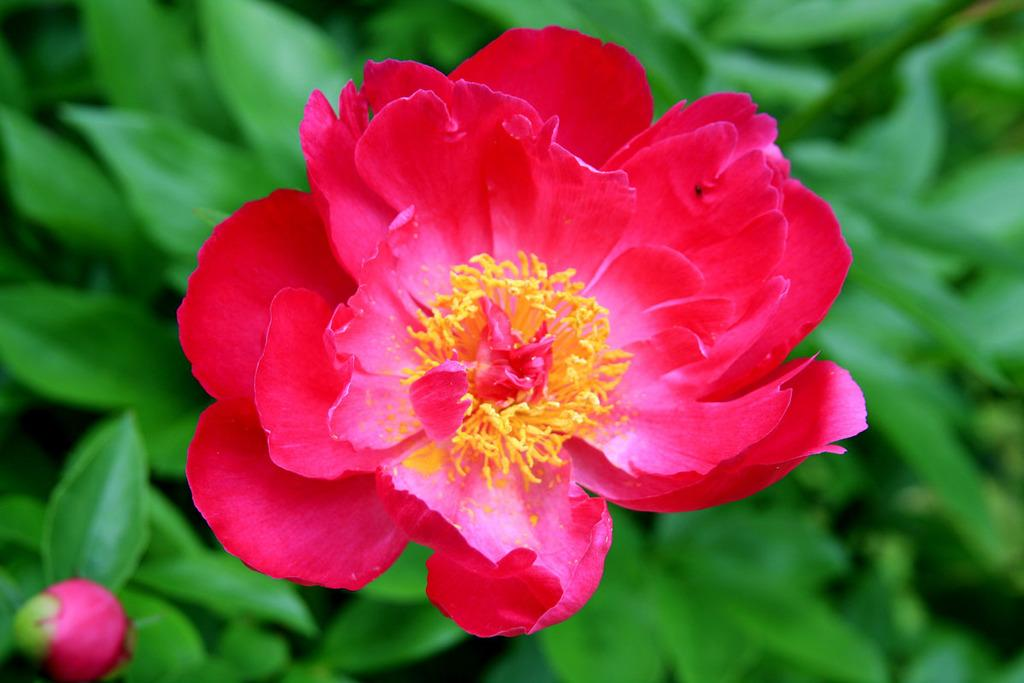What type of plants are present in the image? There are plants with flowers in the image. What colors can be seen on the flowers? The flowers are red and yellow in color. What is the title of the alley in the image? There is no alley present in the image, and therefore no title can be assigned to it. 